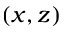Convert formula to latex. <formula><loc_0><loc_0><loc_500><loc_500>( x , z )</formula> 